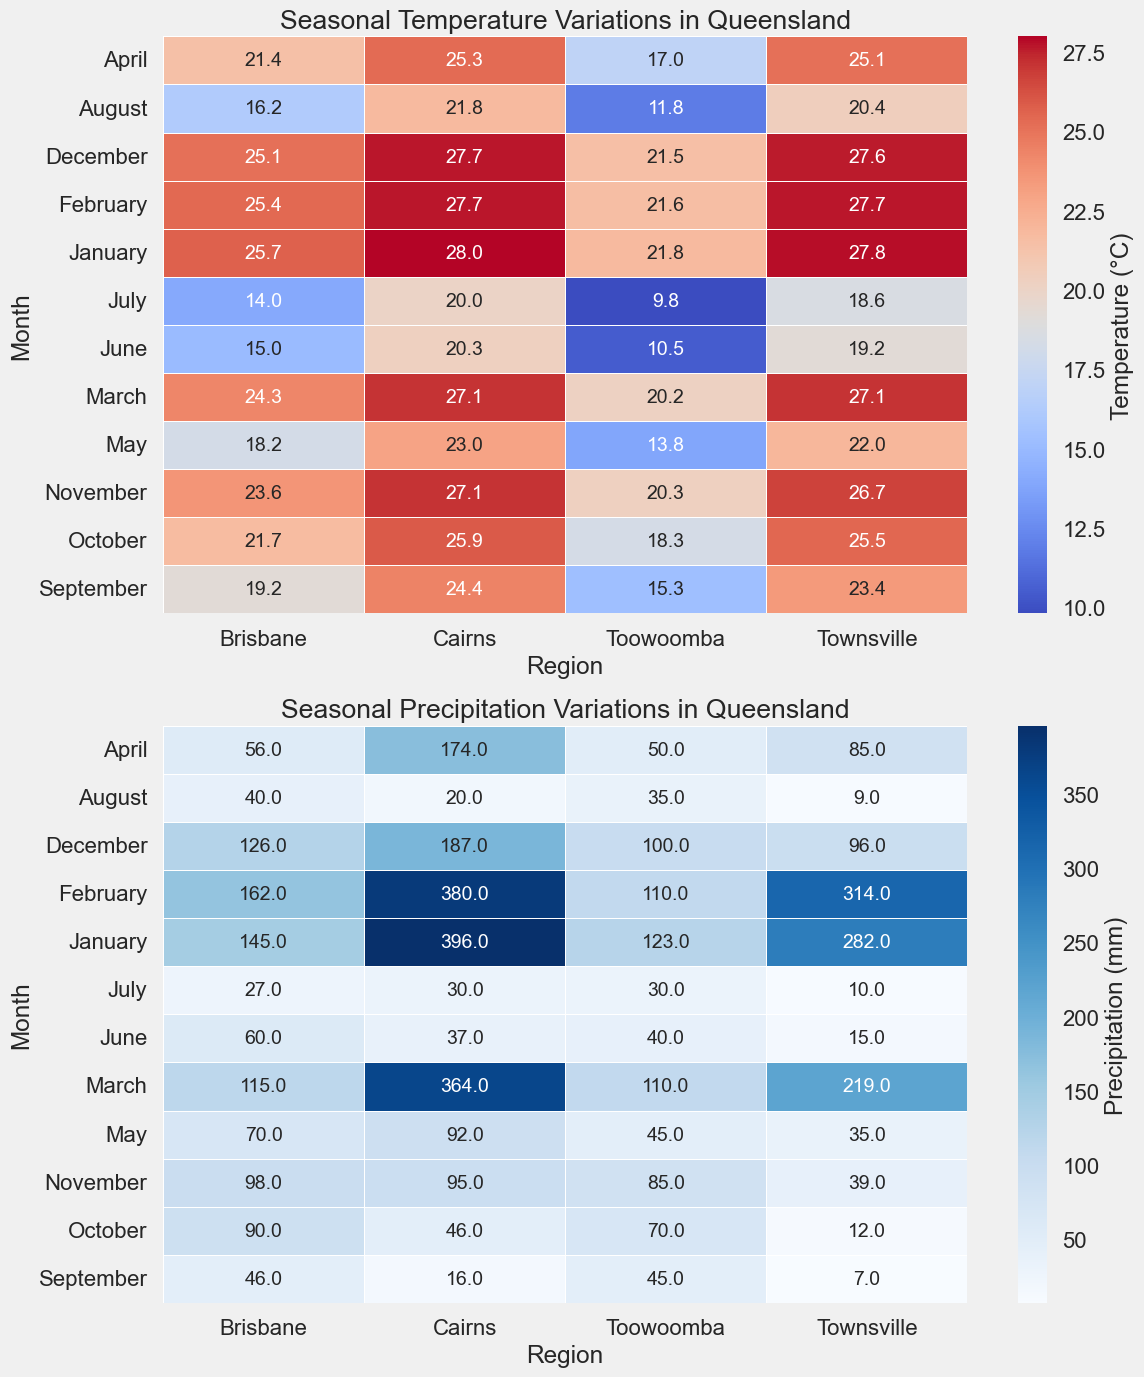What is the average temperature for Brisbane in the first quarter of the year? To calculate the average temperature for Brisbane in the first quarter (January, February, and March), first add up the temperatures for these months: 25.7°C + 25.4°C + 24.3°C = 75.4°C. Then, divide by the number of months: 75.4°C / 3 = 25.13°C
Answer: 25.1°C During which month does Cairns experience its highest precipitation? Look at the heatmap for precipitation and identify the darkest blue cell in the row corresponding to Cairns. The darkest blue for Cairns is in January with a precipitation of 396 mm.
Answer: January How do the temperatures of Townsville compare between July and August? Examine the temperature heatmap and locate the temperatures of Townsville for July and August. In July, it’s 18.6°C, and in August, it is 20.4°C. August is warmer than July.
Answer: August is warmer What is the total precipitation for Toowoomba in the second half of the year? Sum the precipitation values for Toowoomba from July to December: 30 mm (July) + 35 mm (August) + 45 mm (September) + 70 mm (October) + 85 mm (November) + 100 mm (December) = 365 mm.
Answer: 365 mm Which month has the highest average temperature across all regions? To find the month with the highest average temperature, first note down the temperatures for all regions for each month, compute their averages, and compare. January has high values across all regions (25.7°C for Brisbane, 28°C for Cairns, 21.8°C for Toowoomba, and 27.8°C for Townsville). The highest average temperature is in January.
Answer: January In Brisbane, which season has the least precipitation? Examine the precipitation heatmap and check Brisbane's values for each season. Sum the monthly values per season: 
- Summer (Dec-Feb): 126 mm + 145 mm + 162 mm = 433 mm
- Autumn (Mar-May): 115 mm + 56 mm + 70 mm = 241 mm
- Winter (Jun-Aug): 60 mm + 27 mm + 40 mm = 127 mm
- Spring (Sep-Nov): 46 mm + 90 mm + 98 mm = 234 mm
Winter has the least precipitation.
Answer: Winter Identify the region with the most consistent temperature throughout the year. Look at the temperature heatmap to determine the consistency or minimal variation in temperature throughout the months. Cairns shows a small range in values from 20°C to 28°C, indicating high consistency.
Answer: Cairns Which region experiences its lowest precipitation in October, and what is the value? Check the precipitation heatmap for the month of October and identify the region with the lightest blue cell, which indicates the lowest precipitation. Townsville has the lowest precipitation at 12 mm.
Answer: Townsville, 12 mm 